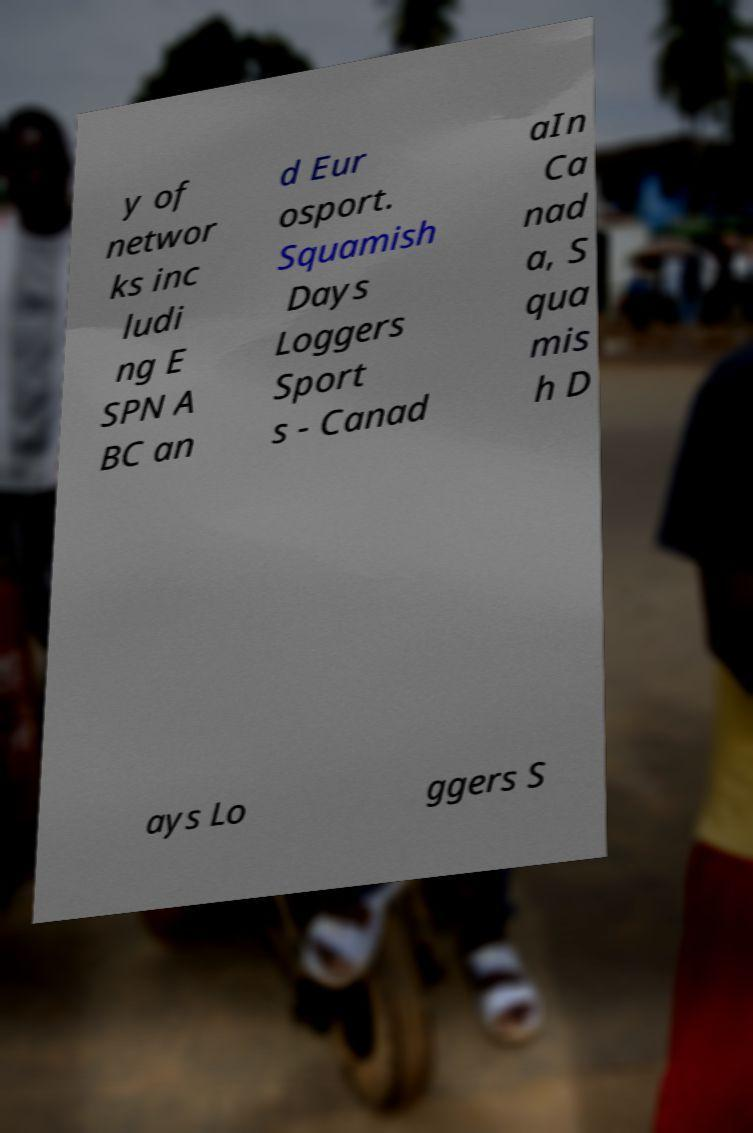What messages or text are displayed in this image? I need them in a readable, typed format. y of networ ks inc ludi ng E SPN A BC an d Eur osport. Squamish Days Loggers Sport s - Canad aIn Ca nad a, S qua mis h D ays Lo ggers S 